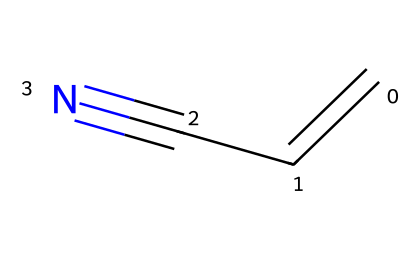What is the functional group present in acrylonitrile? Acrylonitrile has a nitrile functional group, characterized by the presence of a carbon triple-bonded to a nitrogen atom (C#N).
Answer: nitrile How many carbon atoms are in the structure of acrylonitrile? The SMILES representation shows two carbon atoms (C in C=CC#N).
Answer: 2 What type of bond connects the carbon atoms in the double bond of acrylonitrile? In acrylonitrile, there is a double bond between the first and second carbon atoms (C=C) indicating a pi and sigma bond structure.
Answer: double bond What is the total number of atoms in the chemical structure of acrylonitrile? Counting the atoms in the provided SMILES (2 carbons, 3 hydrogens, and 1 nitrogen), the total comes to six atoms.
Answer: 6 What type of chemical is acrylonitrile classified as? Acrylonitrile fits into the category of unsaturated nitriles owing to its carbon-carbon double bond and the presence of a nitrile group.
Answer: unsaturated nitrile Why does acrylonitrile have a high polymerization potential? The presence of a double bond (C=C) in conjunction with the nitrile functional group (C#N) enhances its reactivity, allowing it to undergo polymerization easily.
Answer: reactivity What is the hybridization of the carbon atoms in acrylonitrile? Analyzing the structure reveals that the first carbon is sp2 hybridized (due to the double bond) and the second carbon is sp hybridized (due to its triple bond with nitrogen).
Answer: sp2 and sp 